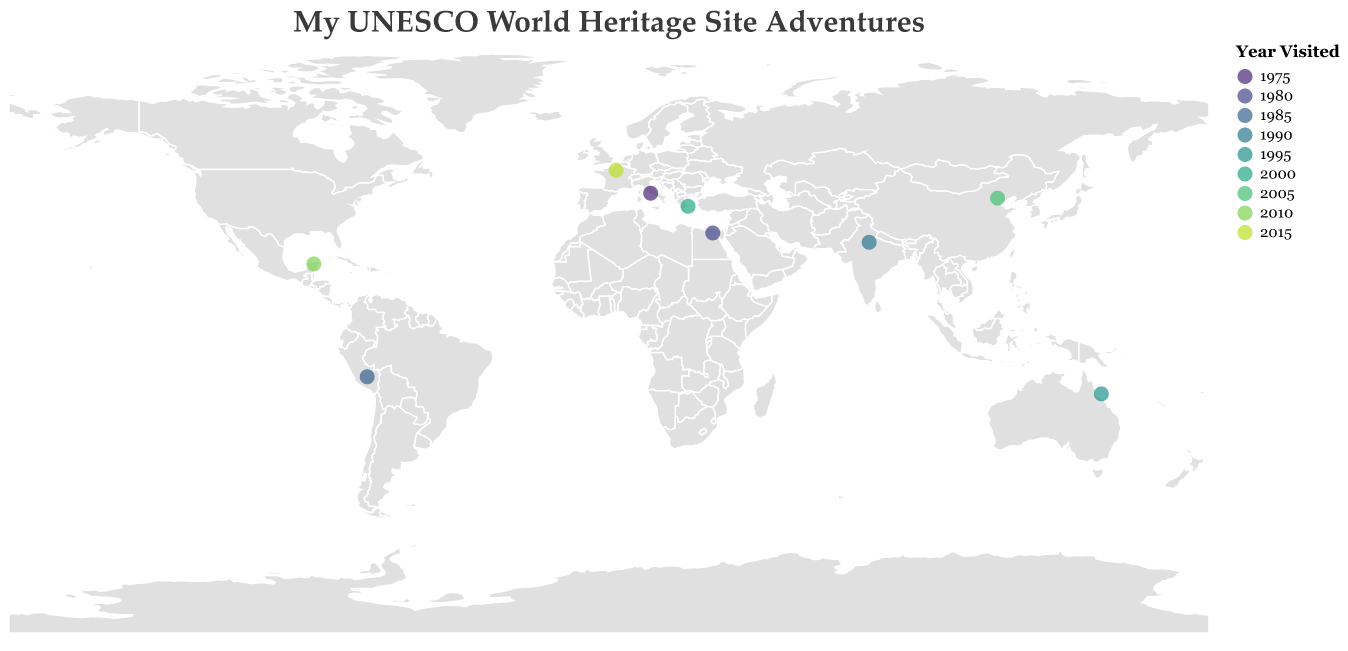What is the title of the plot? The title of the plot is displayed at the top in a larger font and states, "My UNESCO World Heritage Site Adventures".
Answer: My UNESCO World Heritage Site Adventures Which country did I visit first according to the figure? By looking at the color legend for "Year Visited", the color associated with the earliest year (1975) points to Italy, more specifically the Historic Centre of Rome.
Answer: Italy How many sites did I visit during the 2000s? The figure shows sites with a color bar legend indicating the years. By counting the sites with years from 2000 to 2009, we find two such points: Acropolis of Athens (2000) and Great Wall of China (2005).
Answer: 2 Which UNESCO World Heritage Site is located in China according to the plot? By examining the tooltip or hovering over the points, we can see that the site in China is the Great Wall of China.
Answer: Great Wall of China Which site was visited last according to the plot? The site visited last has the most recent year on the color legend. This is Palace and Park of Versailles in France, visited in 2015.
Answer: Palace and Park of Versailles How many sites are located in the Southern Hemisphere? The Southern Hemisphere includes all locations with negative latitudes. The plot shows two such sites: Machu Picchu in Peru and Great Barrier Reef in Australia.
Answer: 2 Which two sites are closest in terms of their latitude and longitude? By comparing the geographical proximity on the plot, The Acropolis of Athens (Greece) and Historic Centre of Rome (Italy) are the closest sites.
Answer: Acropolis of Athens and Historic Centre of Rome Which site has the latitude closest to 20 degrees? The plot gives the latitude values in the tooltip. The Pre-Hispanic City of Chichen-Itza in Mexico has a latitude of approximately 20.6843 degrees.
Answer: Pre-Hispanic City of Chichen-Itza How many sites are on different continents? By using the geographic locations of the sites and assuming the standard definition of continents, the sites are distributed as follows: Europe (2), Asia (2), Africa (1), North America (1), South America (1), Australia (1). Each site is on a different continent, totaling 7 continents accounted for.
Answer: 7 